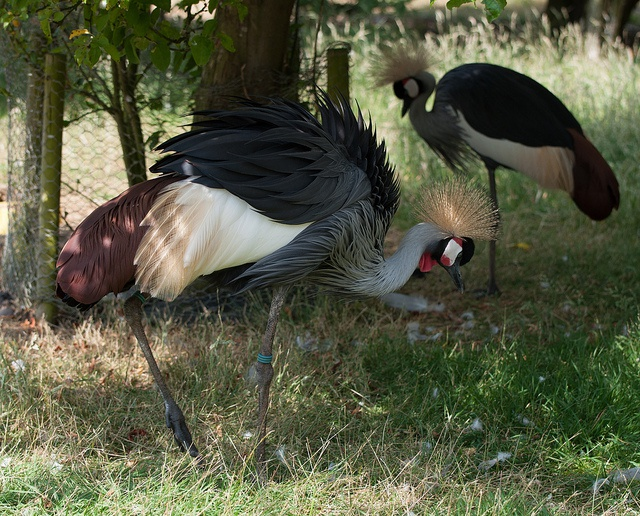Describe the objects in this image and their specific colors. I can see bird in darkgreen, black, gray, darkgray, and maroon tones and bird in darkgreen, black, gray, and olive tones in this image. 